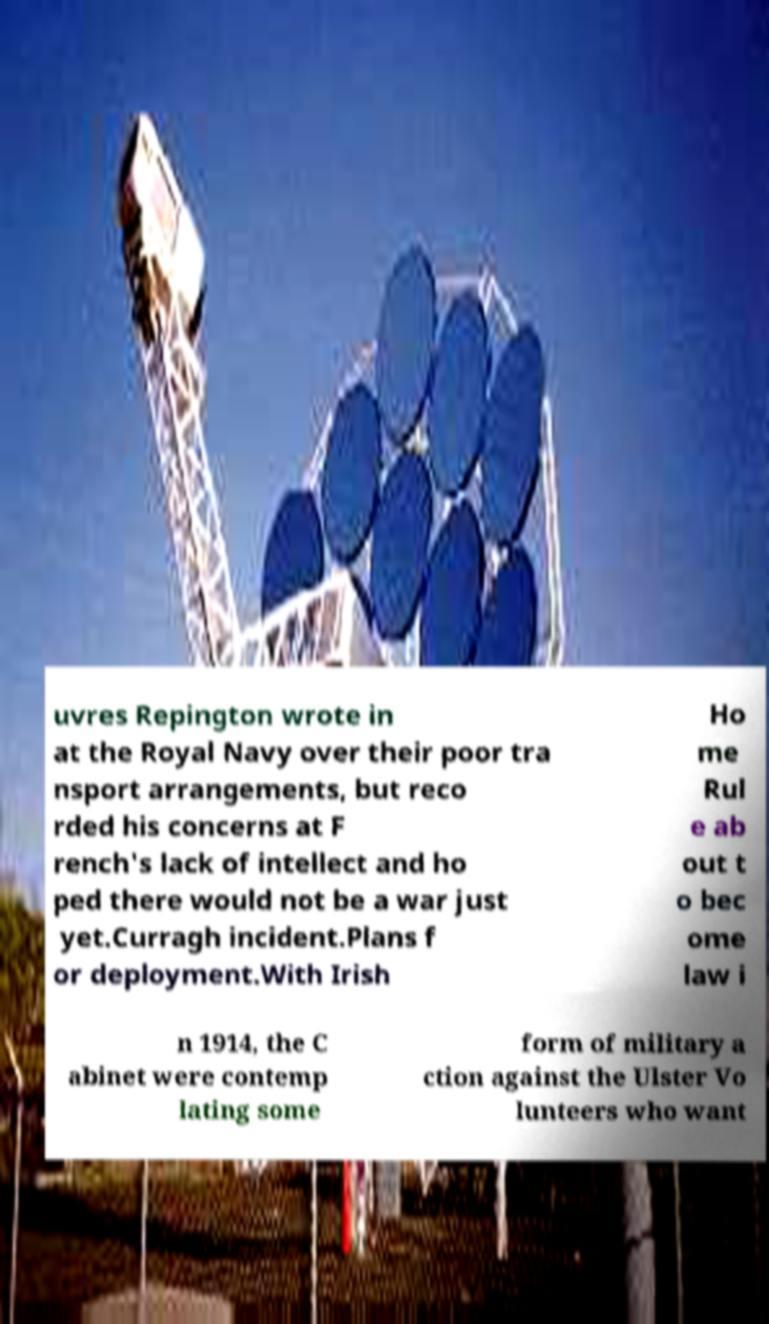For documentation purposes, I need the text within this image transcribed. Could you provide that? uvres Repington wrote in at the Royal Navy over their poor tra nsport arrangements, but reco rded his concerns at F rench's lack of intellect and ho ped there would not be a war just yet.Curragh incident.Plans f or deployment.With Irish Ho me Rul e ab out t o bec ome law i n 1914, the C abinet were contemp lating some form of military a ction against the Ulster Vo lunteers who want 